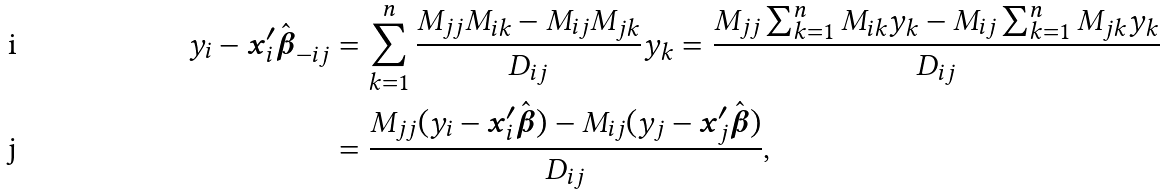Convert formula to latex. <formula><loc_0><loc_0><loc_500><loc_500>y _ { i } - { \boldsymbol x } _ { i } ^ { \prime } \hat { \boldsymbol \beta } _ { - i j } & = \sum _ { k = 1 } ^ { n } \frac { M _ { j j } M _ { i k } - M _ { i j } M _ { j k } } { D _ { i j } } y _ { k } = \frac { M _ { j j } \sum _ { k = 1 } ^ { n } M _ { i k } y _ { k } - M _ { i j } \sum _ { k = 1 } ^ { n } M _ { j k } y _ { k } } { D _ { i j } } \\ & = \frac { M _ { j j } ( y _ { i } - { \boldsymbol x } _ { i } ^ { \prime } \hat { \boldsymbol \beta } ) - M _ { i j } ( y _ { j } - { \boldsymbol x } _ { j } ^ { \prime } \hat { \boldsymbol \beta } ) } { D _ { i j } } ,</formula> 